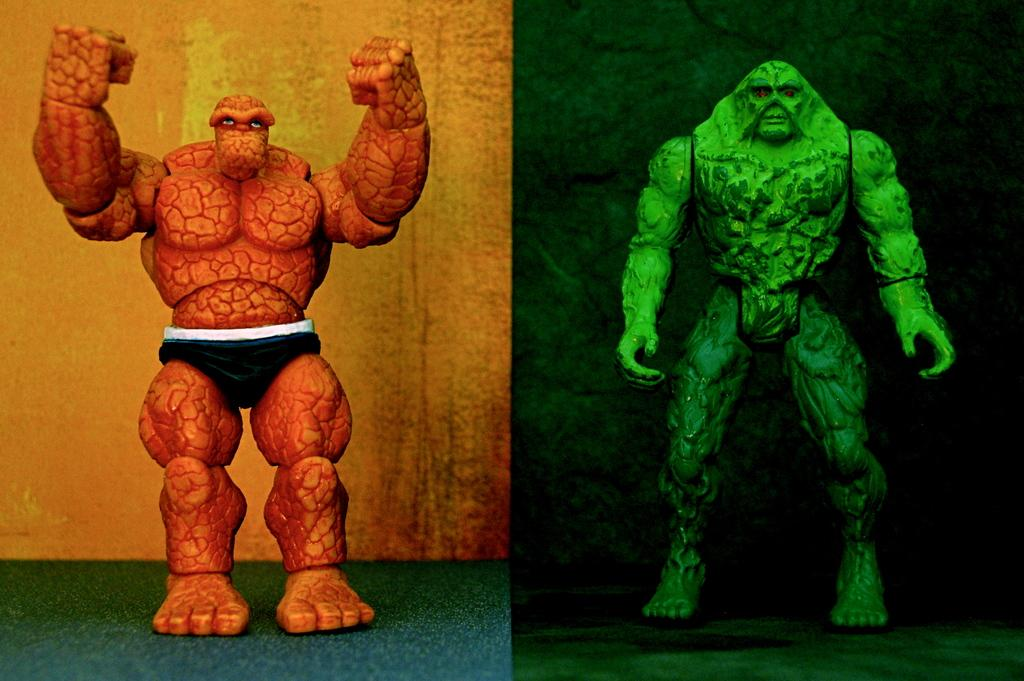How many toys can be seen in the image? There are two toys in the image. How many people are in the crowd surrounding the toys in the image? There is no crowd present in the image; it only features two toys. Are the toys in the image related as brothers? There is no information about the relationship between the toys in the image. 